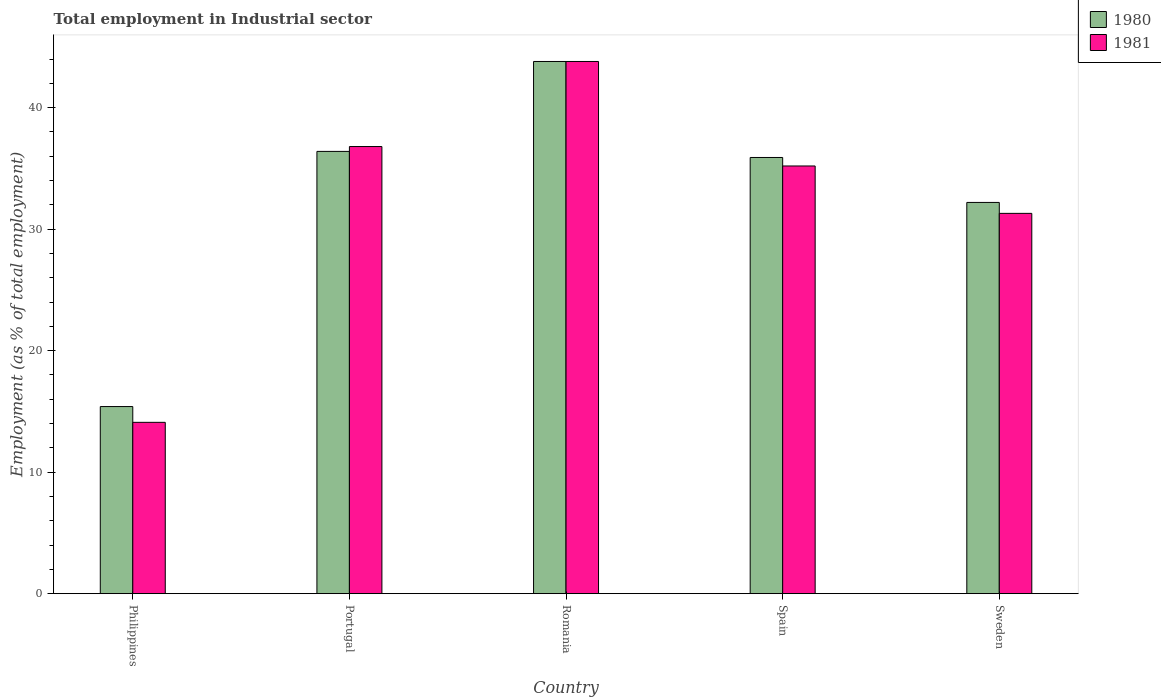Are the number of bars on each tick of the X-axis equal?
Your answer should be very brief. Yes. How many bars are there on the 1st tick from the left?
Your answer should be very brief. 2. What is the label of the 4th group of bars from the left?
Give a very brief answer. Spain. In how many cases, is the number of bars for a given country not equal to the number of legend labels?
Keep it short and to the point. 0. What is the employment in industrial sector in 1981 in Sweden?
Provide a succinct answer. 31.3. Across all countries, what is the maximum employment in industrial sector in 1981?
Keep it short and to the point. 43.8. Across all countries, what is the minimum employment in industrial sector in 1981?
Give a very brief answer. 14.1. In which country was the employment in industrial sector in 1980 maximum?
Offer a terse response. Romania. What is the total employment in industrial sector in 1980 in the graph?
Give a very brief answer. 163.7. What is the difference between the employment in industrial sector in 1981 in Philippines and that in Romania?
Offer a very short reply. -29.7. What is the difference between the employment in industrial sector in 1981 in Romania and the employment in industrial sector in 1980 in Spain?
Offer a terse response. 7.9. What is the average employment in industrial sector in 1981 per country?
Your answer should be very brief. 32.24. What is the difference between the employment in industrial sector of/in 1981 and employment in industrial sector of/in 1980 in Spain?
Provide a succinct answer. -0.7. In how many countries, is the employment in industrial sector in 1981 greater than 18 %?
Make the answer very short. 4. What is the ratio of the employment in industrial sector in 1981 in Philippines to that in Sweden?
Ensure brevity in your answer.  0.45. Is the employment in industrial sector in 1981 in Portugal less than that in Sweden?
Offer a terse response. No. Is the difference between the employment in industrial sector in 1981 in Spain and Sweden greater than the difference between the employment in industrial sector in 1980 in Spain and Sweden?
Your answer should be compact. Yes. What is the difference between the highest and the second highest employment in industrial sector in 1981?
Keep it short and to the point. -8.6. What is the difference between the highest and the lowest employment in industrial sector in 1980?
Your answer should be very brief. 28.4. In how many countries, is the employment in industrial sector in 1980 greater than the average employment in industrial sector in 1980 taken over all countries?
Your answer should be very brief. 3. Is the sum of the employment in industrial sector in 1980 in Philippines and Sweden greater than the maximum employment in industrial sector in 1981 across all countries?
Provide a succinct answer. Yes. What does the 1st bar from the left in Spain represents?
Provide a succinct answer. 1980. How many countries are there in the graph?
Provide a short and direct response. 5. What is the difference between two consecutive major ticks on the Y-axis?
Provide a short and direct response. 10. Does the graph contain any zero values?
Offer a very short reply. No. Does the graph contain grids?
Offer a very short reply. No. How are the legend labels stacked?
Your answer should be very brief. Vertical. What is the title of the graph?
Offer a terse response. Total employment in Industrial sector. Does "1977" appear as one of the legend labels in the graph?
Keep it short and to the point. No. What is the label or title of the X-axis?
Offer a very short reply. Country. What is the label or title of the Y-axis?
Offer a terse response. Employment (as % of total employment). What is the Employment (as % of total employment) of 1980 in Philippines?
Make the answer very short. 15.4. What is the Employment (as % of total employment) in 1981 in Philippines?
Your response must be concise. 14.1. What is the Employment (as % of total employment) of 1980 in Portugal?
Give a very brief answer. 36.4. What is the Employment (as % of total employment) in 1981 in Portugal?
Your response must be concise. 36.8. What is the Employment (as % of total employment) in 1980 in Romania?
Offer a very short reply. 43.8. What is the Employment (as % of total employment) of 1981 in Romania?
Your answer should be compact. 43.8. What is the Employment (as % of total employment) in 1980 in Spain?
Your answer should be compact. 35.9. What is the Employment (as % of total employment) in 1981 in Spain?
Your response must be concise. 35.2. What is the Employment (as % of total employment) in 1980 in Sweden?
Provide a succinct answer. 32.2. What is the Employment (as % of total employment) of 1981 in Sweden?
Ensure brevity in your answer.  31.3. Across all countries, what is the maximum Employment (as % of total employment) of 1980?
Your answer should be very brief. 43.8. Across all countries, what is the maximum Employment (as % of total employment) in 1981?
Offer a terse response. 43.8. Across all countries, what is the minimum Employment (as % of total employment) in 1980?
Your answer should be compact. 15.4. Across all countries, what is the minimum Employment (as % of total employment) in 1981?
Provide a short and direct response. 14.1. What is the total Employment (as % of total employment) in 1980 in the graph?
Give a very brief answer. 163.7. What is the total Employment (as % of total employment) in 1981 in the graph?
Offer a terse response. 161.2. What is the difference between the Employment (as % of total employment) in 1980 in Philippines and that in Portugal?
Provide a short and direct response. -21. What is the difference between the Employment (as % of total employment) of 1981 in Philippines and that in Portugal?
Offer a terse response. -22.7. What is the difference between the Employment (as % of total employment) in 1980 in Philippines and that in Romania?
Provide a short and direct response. -28.4. What is the difference between the Employment (as % of total employment) of 1981 in Philippines and that in Romania?
Make the answer very short. -29.7. What is the difference between the Employment (as % of total employment) of 1980 in Philippines and that in Spain?
Offer a terse response. -20.5. What is the difference between the Employment (as % of total employment) in 1981 in Philippines and that in Spain?
Ensure brevity in your answer.  -21.1. What is the difference between the Employment (as % of total employment) in 1980 in Philippines and that in Sweden?
Keep it short and to the point. -16.8. What is the difference between the Employment (as % of total employment) of 1981 in Philippines and that in Sweden?
Ensure brevity in your answer.  -17.2. What is the difference between the Employment (as % of total employment) in 1980 in Portugal and that in Romania?
Your answer should be compact. -7.4. What is the difference between the Employment (as % of total employment) of 1981 in Portugal and that in Romania?
Give a very brief answer. -7. What is the difference between the Employment (as % of total employment) in 1980 in Portugal and that in Sweden?
Give a very brief answer. 4.2. What is the difference between the Employment (as % of total employment) of 1981 in Portugal and that in Sweden?
Give a very brief answer. 5.5. What is the difference between the Employment (as % of total employment) of 1980 in Romania and that in Sweden?
Your answer should be compact. 11.6. What is the difference between the Employment (as % of total employment) of 1981 in Romania and that in Sweden?
Ensure brevity in your answer.  12.5. What is the difference between the Employment (as % of total employment) in 1980 in Philippines and the Employment (as % of total employment) in 1981 in Portugal?
Give a very brief answer. -21.4. What is the difference between the Employment (as % of total employment) in 1980 in Philippines and the Employment (as % of total employment) in 1981 in Romania?
Offer a terse response. -28.4. What is the difference between the Employment (as % of total employment) of 1980 in Philippines and the Employment (as % of total employment) of 1981 in Spain?
Keep it short and to the point. -19.8. What is the difference between the Employment (as % of total employment) of 1980 in Philippines and the Employment (as % of total employment) of 1981 in Sweden?
Make the answer very short. -15.9. What is the difference between the Employment (as % of total employment) of 1980 in Portugal and the Employment (as % of total employment) of 1981 in Romania?
Give a very brief answer. -7.4. What is the average Employment (as % of total employment) of 1980 per country?
Make the answer very short. 32.74. What is the average Employment (as % of total employment) of 1981 per country?
Your answer should be compact. 32.24. What is the difference between the Employment (as % of total employment) of 1980 and Employment (as % of total employment) of 1981 in Philippines?
Your response must be concise. 1.3. What is the difference between the Employment (as % of total employment) of 1980 and Employment (as % of total employment) of 1981 in Romania?
Offer a terse response. 0. What is the difference between the Employment (as % of total employment) in 1980 and Employment (as % of total employment) in 1981 in Spain?
Provide a short and direct response. 0.7. What is the ratio of the Employment (as % of total employment) of 1980 in Philippines to that in Portugal?
Your answer should be very brief. 0.42. What is the ratio of the Employment (as % of total employment) in 1981 in Philippines to that in Portugal?
Provide a short and direct response. 0.38. What is the ratio of the Employment (as % of total employment) of 1980 in Philippines to that in Romania?
Your answer should be very brief. 0.35. What is the ratio of the Employment (as % of total employment) in 1981 in Philippines to that in Romania?
Ensure brevity in your answer.  0.32. What is the ratio of the Employment (as % of total employment) of 1980 in Philippines to that in Spain?
Give a very brief answer. 0.43. What is the ratio of the Employment (as % of total employment) of 1981 in Philippines to that in Spain?
Your answer should be very brief. 0.4. What is the ratio of the Employment (as % of total employment) of 1980 in Philippines to that in Sweden?
Make the answer very short. 0.48. What is the ratio of the Employment (as % of total employment) of 1981 in Philippines to that in Sweden?
Offer a very short reply. 0.45. What is the ratio of the Employment (as % of total employment) of 1980 in Portugal to that in Romania?
Make the answer very short. 0.83. What is the ratio of the Employment (as % of total employment) in 1981 in Portugal to that in Romania?
Make the answer very short. 0.84. What is the ratio of the Employment (as % of total employment) of 1980 in Portugal to that in Spain?
Ensure brevity in your answer.  1.01. What is the ratio of the Employment (as % of total employment) of 1981 in Portugal to that in Spain?
Offer a terse response. 1.05. What is the ratio of the Employment (as % of total employment) in 1980 in Portugal to that in Sweden?
Ensure brevity in your answer.  1.13. What is the ratio of the Employment (as % of total employment) in 1981 in Portugal to that in Sweden?
Your response must be concise. 1.18. What is the ratio of the Employment (as % of total employment) of 1980 in Romania to that in Spain?
Ensure brevity in your answer.  1.22. What is the ratio of the Employment (as % of total employment) in 1981 in Romania to that in Spain?
Your answer should be very brief. 1.24. What is the ratio of the Employment (as % of total employment) of 1980 in Romania to that in Sweden?
Ensure brevity in your answer.  1.36. What is the ratio of the Employment (as % of total employment) in 1981 in Romania to that in Sweden?
Ensure brevity in your answer.  1.4. What is the ratio of the Employment (as % of total employment) of 1980 in Spain to that in Sweden?
Ensure brevity in your answer.  1.11. What is the ratio of the Employment (as % of total employment) of 1981 in Spain to that in Sweden?
Keep it short and to the point. 1.12. What is the difference between the highest and the second highest Employment (as % of total employment) in 1980?
Ensure brevity in your answer.  7.4. What is the difference between the highest and the second highest Employment (as % of total employment) of 1981?
Your answer should be compact. 7. What is the difference between the highest and the lowest Employment (as % of total employment) in 1980?
Give a very brief answer. 28.4. What is the difference between the highest and the lowest Employment (as % of total employment) in 1981?
Offer a terse response. 29.7. 